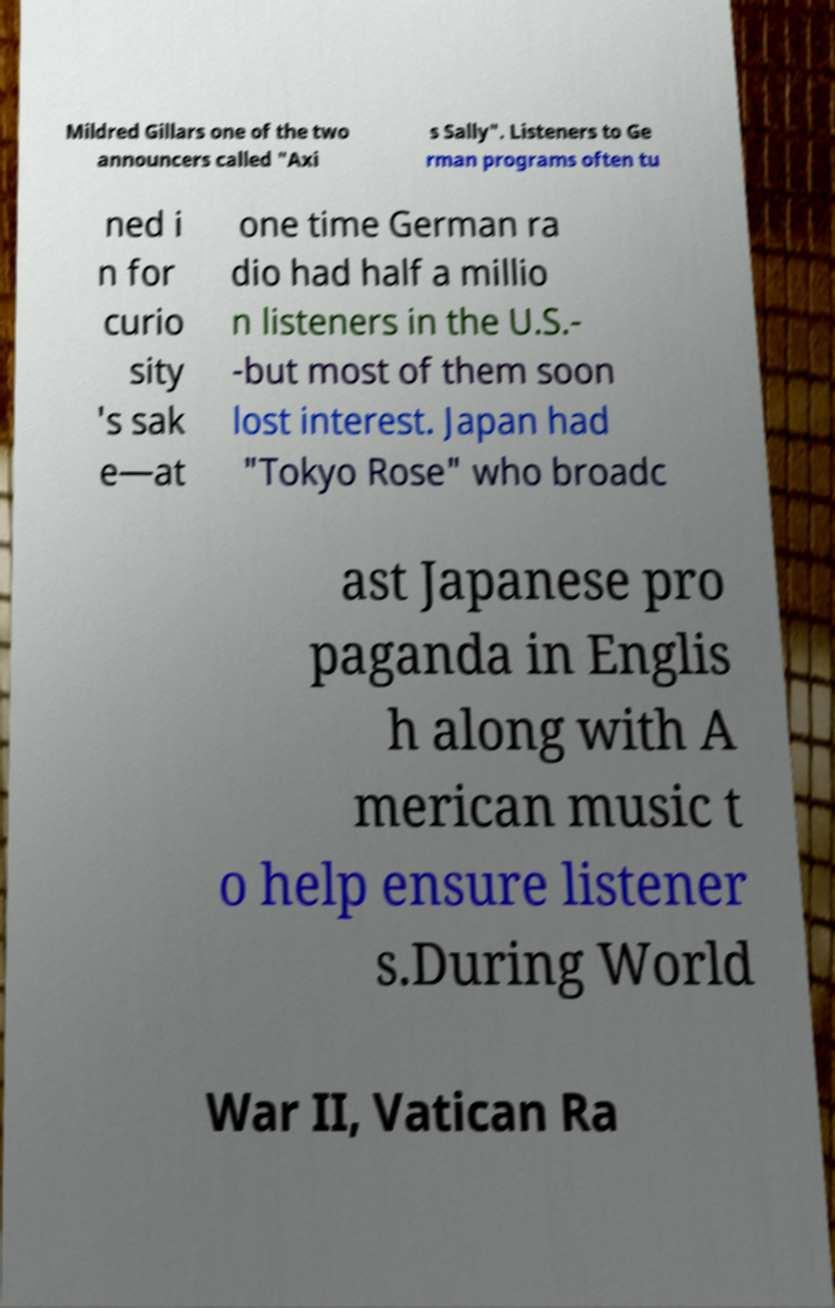Please read and relay the text visible in this image. What does it say? Mildred Gillars one of the two announcers called "Axi s Sally". Listeners to Ge rman programs often tu ned i n for curio sity 's sak e—at one time German ra dio had half a millio n listeners in the U.S.- -but most of them soon lost interest. Japan had "Tokyo Rose" who broadc ast Japanese pro paganda in Englis h along with A merican music t o help ensure listener s.During World War II, Vatican Ra 